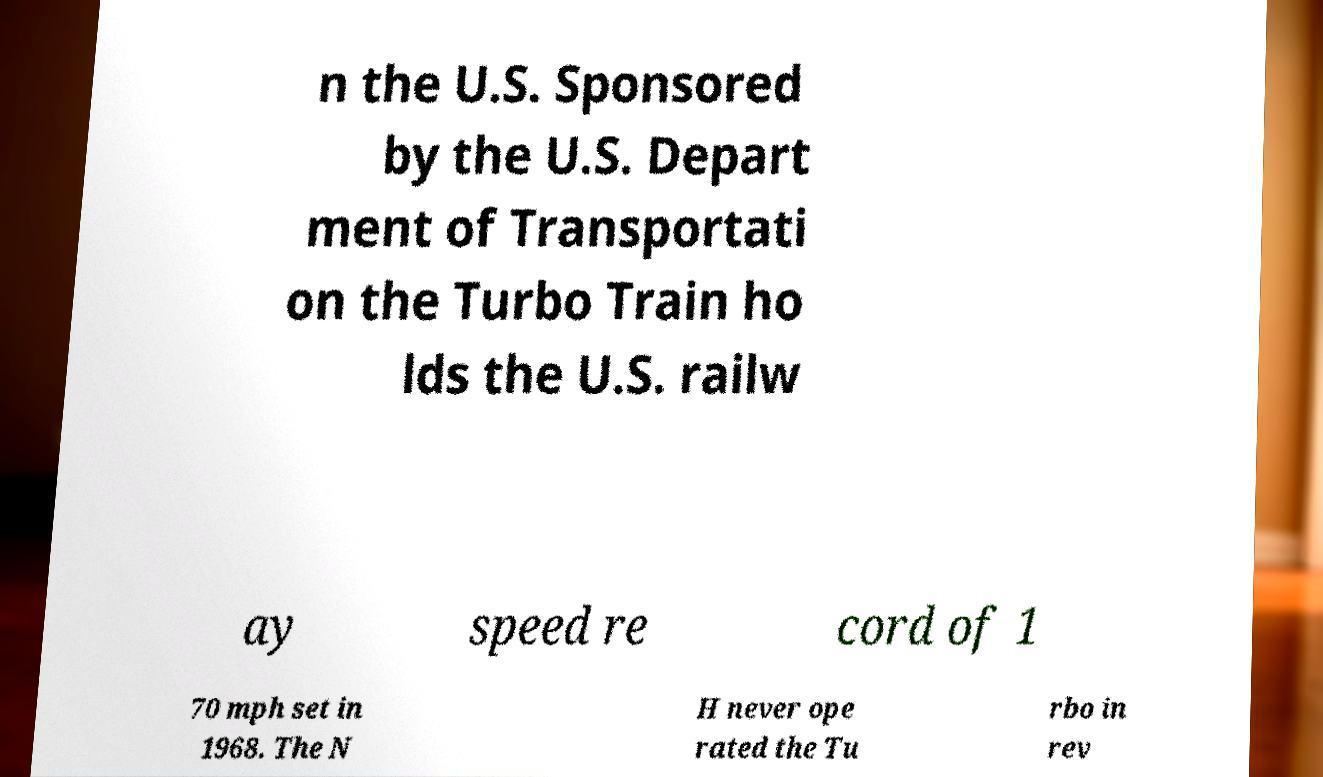Could you assist in decoding the text presented in this image and type it out clearly? n the U.S. Sponsored by the U.S. Depart ment of Transportati on the Turbo Train ho lds the U.S. railw ay speed re cord of 1 70 mph set in 1968. The N H never ope rated the Tu rbo in rev 